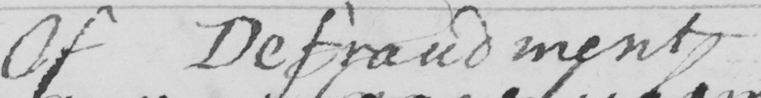Please provide the text content of this handwritten line. Of Defraudment 